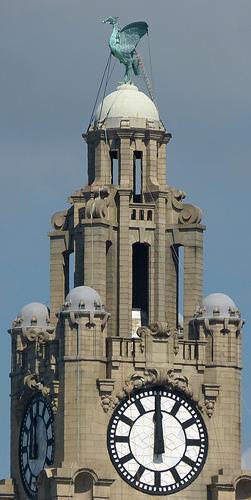How many birds are there?
Give a very brief answer. 1. 